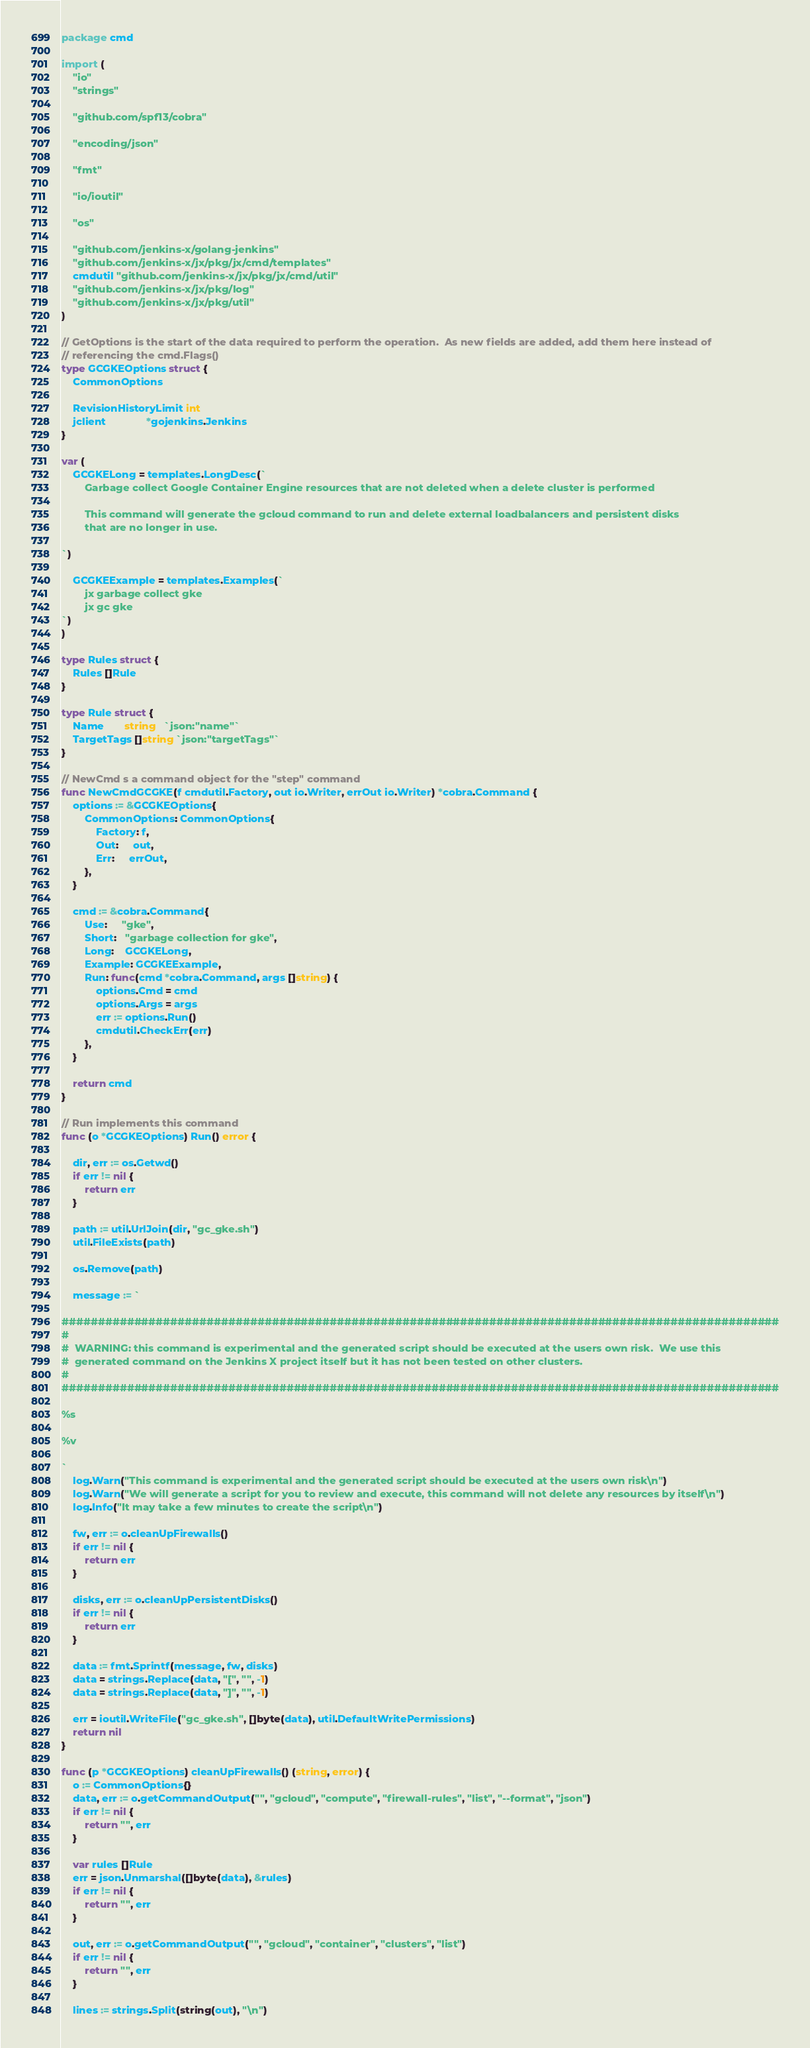Convert code to text. <code><loc_0><loc_0><loc_500><loc_500><_Go_>package cmd

import (
	"io"
	"strings"

	"github.com/spf13/cobra"

	"encoding/json"

	"fmt"

	"io/ioutil"

	"os"

	"github.com/jenkins-x/golang-jenkins"
	"github.com/jenkins-x/jx/pkg/jx/cmd/templates"
	cmdutil "github.com/jenkins-x/jx/pkg/jx/cmd/util"
	"github.com/jenkins-x/jx/pkg/log"
	"github.com/jenkins-x/jx/pkg/util"
)

// GetOptions is the start of the data required to perform the operation.  As new fields are added, add them here instead of
// referencing the cmd.Flags()
type GCGKEOptions struct {
	CommonOptions

	RevisionHistoryLimit int
	jclient              *gojenkins.Jenkins
}

var (
	GCGKELong = templates.LongDesc(`
		Garbage collect Google Container Engine resources that are not deleted when a delete cluster is performed

		This command will generate the gcloud command to run and delete external loadbalancers and persistent disks
		that are no longer in use.

`)

	GCGKEExample = templates.Examples(`
		jx garbage collect gke
		jx gc gke
`)
)

type Rules struct {
	Rules []Rule
}

type Rule struct {
	Name       string   `json:"name"`
	TargetTags []string `json:"targetTags"`
}

// NewCmd s a command object for the "step" command
func NewCmdGCGKE(f cmdutil.Factory, out io.Writer, errOut io.Writer) *cobra.Command {
	options := &GCGKEOptions{
		CommonOptions: CommonOptions{
			Factory: f,
			Out:     out,
			Err:     errOut,
		},
	}

	cmd := &cobra.Command{
		Use:     "gke",
		Short:   "garbage collection for gke",
		Long:    GCGKELong,
		Example: GCGKEExample,
		Run: func(cmd *cobra.Command, args []string) {
			options.Cmd = cmd
			options.Args = args
			err := options.Run()
			cmdutil.CheckErr(err)
		},
	}

	return cmd
}

// Run implements this command
func (o *GCGKEOptions) Run() error {

	dir, err := os.Getwd()
	if err != nil {
		return err
	}

	path := util.UrlJoin(dir, "gc_gke.sh")
	util.FileExists(path)

	os.Remove(path)

	message := `

###################################################################################################
#
#  WARNING: this command is experimental and the generated script should be executed at the users own risk.  We use this
#  generated command on the Jenkins X project itself but it has not been tested on other clusters.
#
###################################################################################################

%s

%v

`
	log.Warn("This command is experimental and the generated script should be executed at the users own risk\n")
	log.Warn("We will generate a script for you to review and execute, this command will not delete any resources by itself\n")
	log.Info("It may take a few minutes to create the script\n")

	fw, err := o.cleanUpFirewalls()
	if err != nil {
		return err
	}

	disks, err := o.cleanUpPersistentDisks()
	if err != nil {
		return err
	}

	data := fmt.Sprintf(message, fw, disks)
	data = strings.Replace(data, "[", "", -1)
	data = strings.Replace(data, "]", "", -1)

	err = ioutil.WriteFile("gc_gke.sh", []byte(data), util.DefaultWritePermissions)
	return nil
}

func (p *GCGKEOptions) cleanUpFirewalls() (string, error) {
	o := CommonOptions{}
	data, err := o.getCommandOutput("", "gcloud", "compute", "firewall-rules", "list", "--format", "json")
	if err != nil {
		return "", err
	}

	var rules []Rule
	err = json.Unmarshal([]byte(data), &rules)
	if err != nil {
		return "", err
	}

	out, err := o.getCommandOutput("", "gcloud", "container", "clusters", "list")
	if err != nil {
		return "", err
	}

	lines := strings.Split(string(out), "\n")</code> 